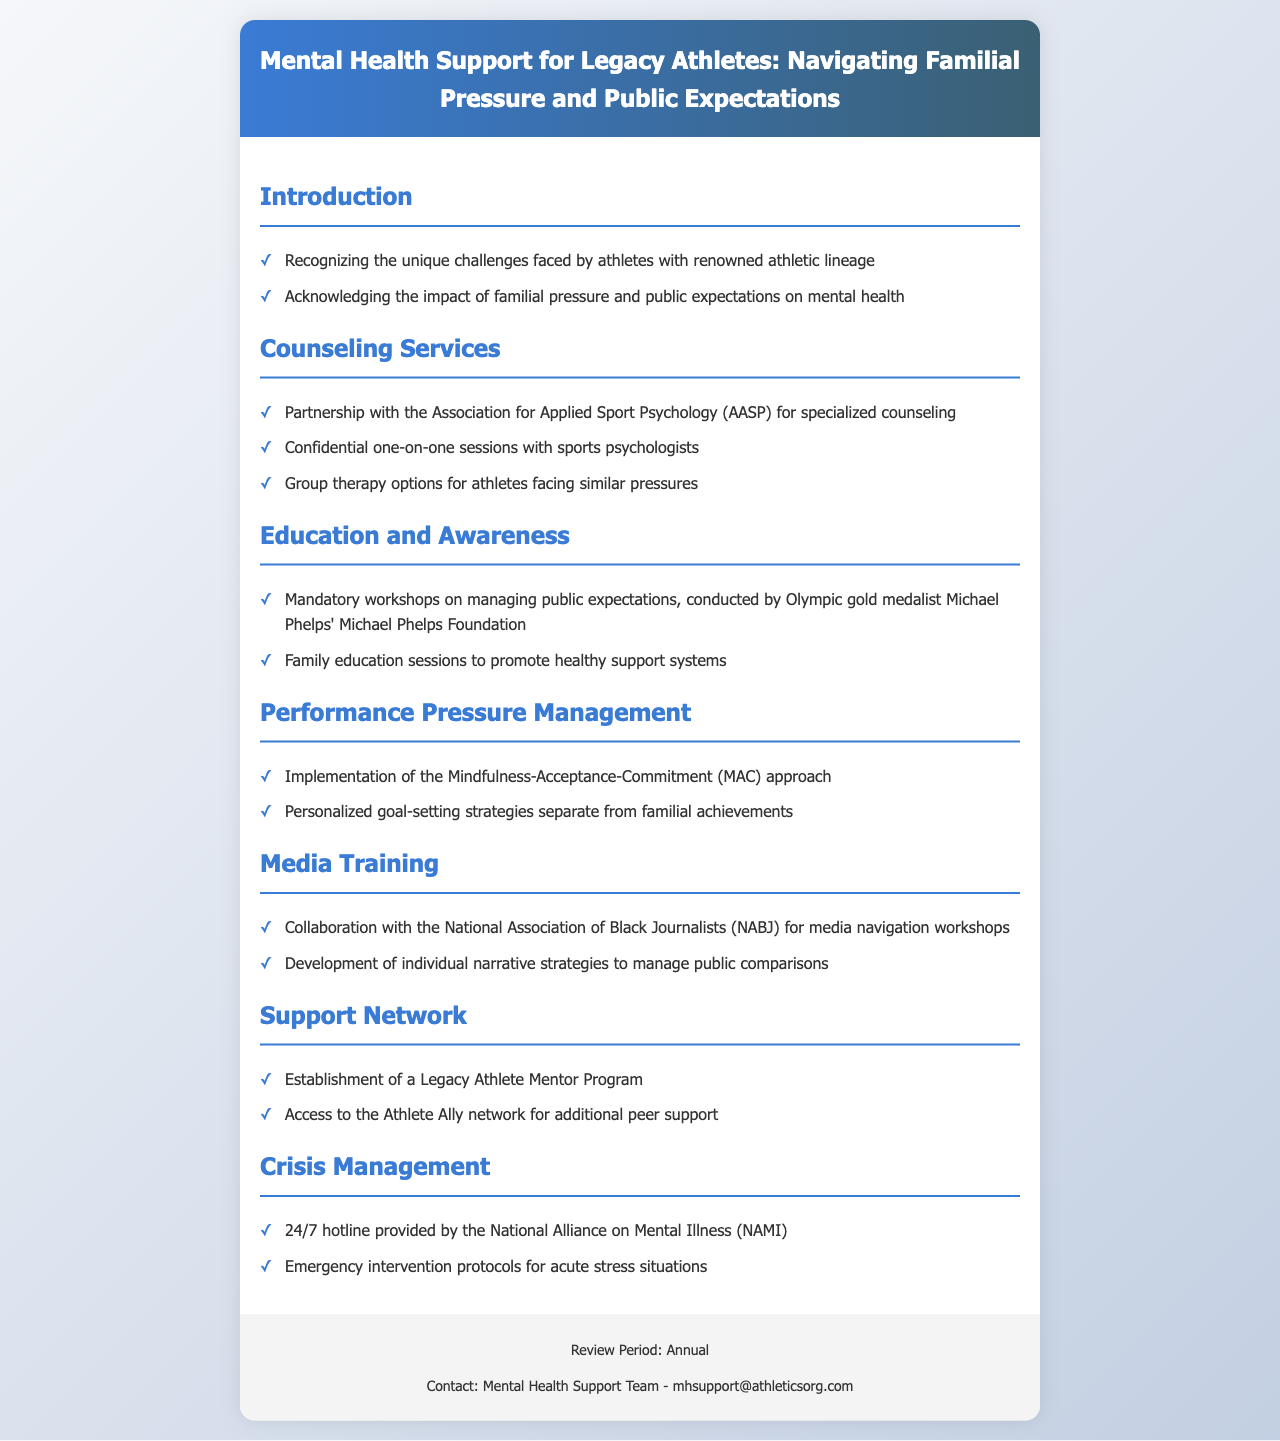what is the title of the document? The title presents the main focus of the document, which is the mental health support policies for athletes dealing with familial pressure.
Answer: Mental Health Support for Legacy Athletes: Navigating Familial Pressure and Public Expectations what organization partners for counseling services? The document states that there is a partnership with a specific organization to provide specialized counseling for athletes.
Answer: Association for Applied Sport Psychology (AASP) who conducts mandatory workshops on managing public expectations? A notable Olympic athlete's foundation is mentioned as conducting workshops for athletes facing public expectations.
Answer: Michael Phelps Foundation which approach is implemented for performance pressure management? The document outlines a specific mental health approach aimed at helping athletes manage performance pressures effectively.
Answer: Mindfulness-Acceptance-Commitment (MAC) what type of program is established for support networks? The document mentions a specific program aimed at providing mentorship and support for legacy athletes.
Answer: Legacy Athlete Mentor Program how can athletes access peer support? The document refers to a specific network that provides additional peer support for athletes.
Answer: Athlete Ally network what is provided by NAMI for crisis management? The document specifies a resource available for athletes in crisis situations related to mental health.
Answer: 24/7 hotline how often will the policy document be reviewed? The review frequency for the policy is mentioned, indicating how often it will be reassessed.
Answer: Annual 